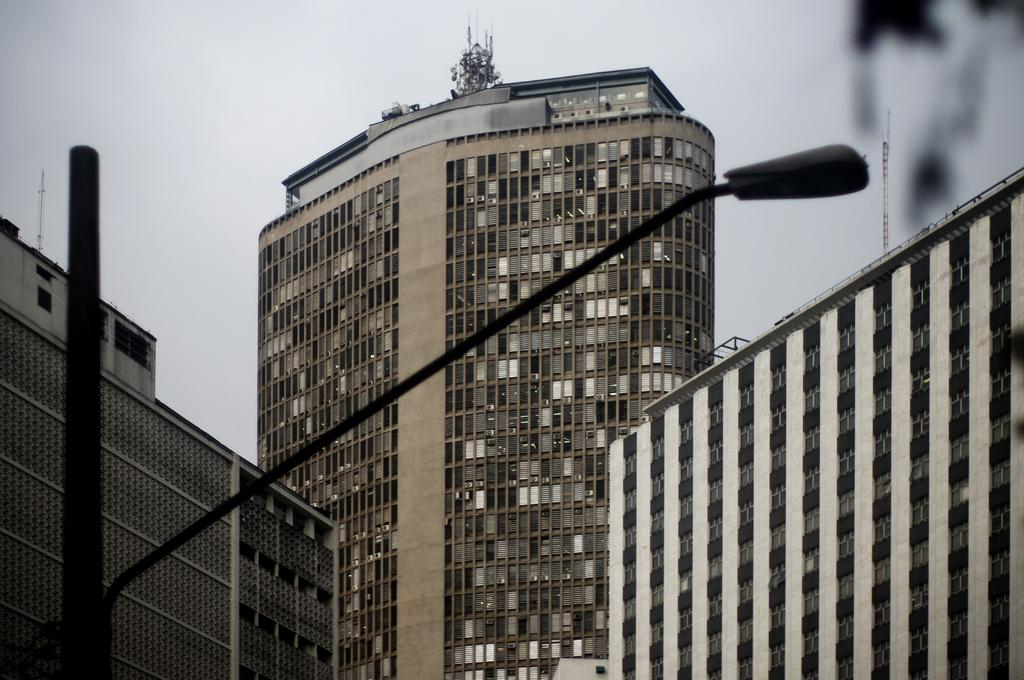What is the main object in the foreground of the image? There is a pole in the image. What is attached to the pole in the image? There is a street light attached to the pole. What can be seen in the background of the image? There are buildings and the sky visible in the background of the image. How many teeth can be seen on the calendar in the image? There is no calendar or teeth present in the image. 